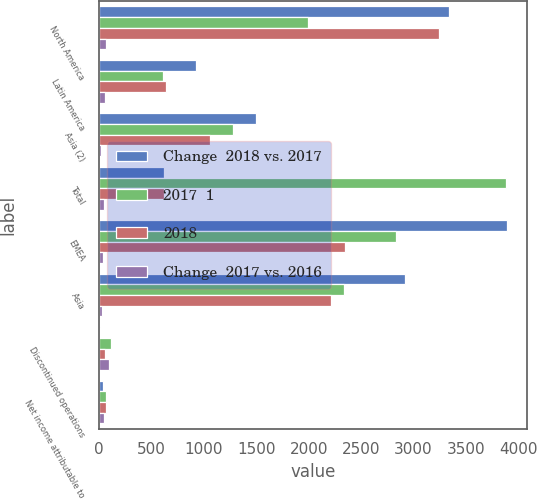Convert chart. <chart><loc_0><loc_0><loc_500><loc_500><stacked_bar_chart><ecel><fcel>North America<fcel>Latin America<fcel>Asia (2)<fcel>Total<fcel>EMEA<fcel>Asia<fcel>Discontinued operations<fcel>Net income attributable to<nl><fcel>Change  2018 vs. 2017<fcel>3340<fcel>928<fcel>1494<fcel>621.5<fcel>3891<fcel>2920<fcel>8<fcel>35<nl><fcel>2017  1<fcel>1990<fcel>610<fcel>1278<fcel>3878<fcel>2832<fcel>2335<fcel>111<fcel>60<nl><fcel>2018<fcel>3239<fcel>633<fcel>1059<fcel>621.5<fcel>2345<fcel>2211<fcel>58<fcel>63<nl><fcel>Change  2017 vs. 2016<fcel>68<fcel>52<fcel>17<fcel>49<fcel>37<fcel>25<fcel>93<fcel>42<nl></chart> 